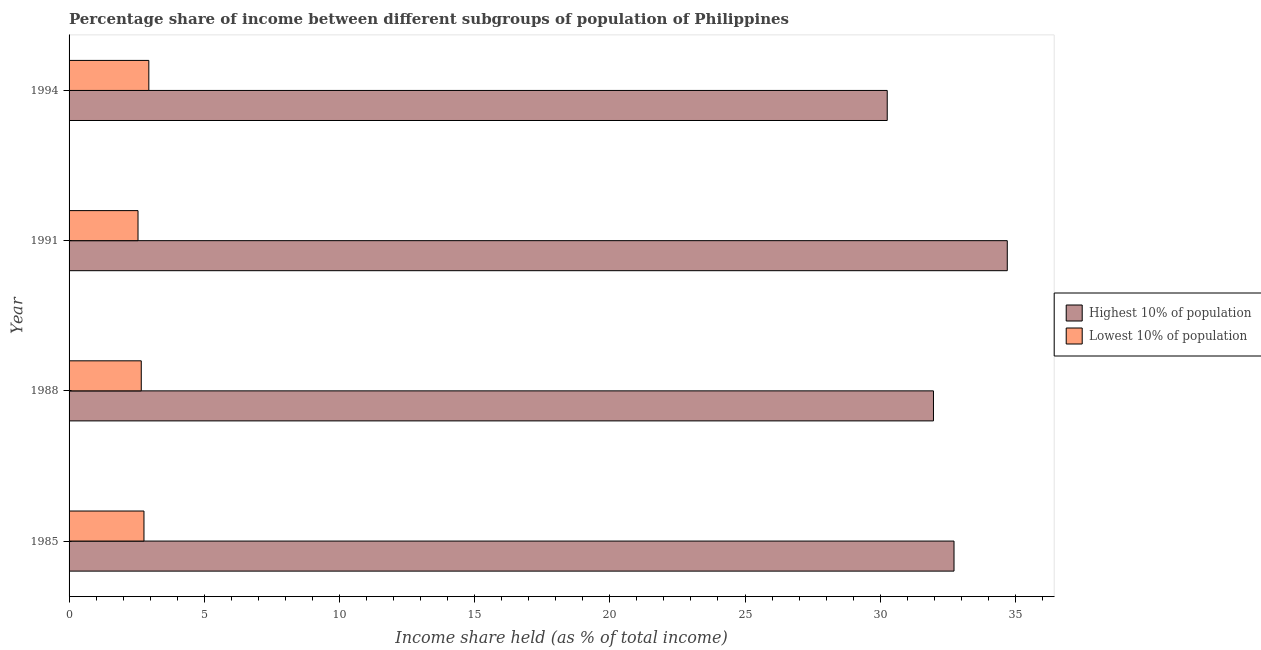How many groups of bars are there?
Make the answer very short. 4. Are the number of bars on each tick of the Y-axis equal?
Provide a succinct answer. Yes. How many bars are there on the 1st tick from the bottom?
Your answer should be compact. 2. What is the income share held by lowest 10% of the population in 1994?
Offer a terse response. 2.95. Across all years, what is the maximum income share held by highest 10% of the population?
Offer a terse response. 34.7. Across all years, what is the minimum income share held by lowest 10% of the population?
Provide a succinct answer. 2.55. In which year was the income share held by lowest 10% of the population minimum?
Offer a terse response. 1991. What is the total income share held by lowest 10% of the population in the graph?
Your answer should be compact. 10.94. What is the difference between the income share held by highest 10% of the population in 1985 and that in 1991?
Your response must be concise. -1.97. What is the difference between the income share held by lowest 10% of the population in 1991 and the income share held by highest 10% of the population in 1994?
Make the answer very short. -27.71. What is the average income share held by lowest 10% of the population per year?
Ensure brevity in your answer.  2.73. In the year 1988, what is the difference between the income share held by lowest 10% of the population and income share held by highest 10% of the population?
Your answer should be very brief. -29.3. In how many years, is the income share held by highest 10% of the population greater than 33 %?
Give a very brief answer. 1. What is the ratio of the income share held by lowest 10% of the population in 1988 to that in 1991?
Keep it short and to the point. 1.05. Is the difference between the income share held by lowest 10% of the population in 1988 and 1991 greater than the difference between the income share held by highest 10% of the population in 1988 and 1991?
Provide a succinct answer. Yes. What is the difference between the highest and the second highest income share held by highest 10% of the population?
Provide a succinct answer. 1.97. What is the difference between the highest and the lowest income share held by lowest 10% of the population?
Keep it short and to the point. 0.4. What does the 1st bar from the top in 1985 represents?
Provide a succinct answer. Lowest 10% of population. What does the 1st bar from the bottom in 1988 represents?
Offer a terse response. Highest 10% of population. Are all the bars in the graph horizontal?
Provide a succinct answer. Yes. How many years are there in the graph?
Keep it short and to the point. 4. Are the values on the major ticks of X-axis written in scientific E-notation?
Provide a succinct answer. No. Does the graph contain any zero values?
Your answer should be compact. No. Does the graph contain grids?
Offer a terse response. No. How are the legend labels stacked?
Your answer should be compact. Vertical. What is the title of the graph?
Keep it short and to the point. Percentage share of income between different subgroups of population of Philippines. What is the label or title of the X-axis?
Offer a terse response. Income share held (as % of total income). What is the Income share held (as % of total income) in Highest 10% of population in 1985?
Offer a very short reply. 32.73. What is the Income share held (as % of total income) in Lowest 10% of population in 1985?
Give a very brief answer. 2.77. What is the Income share held (as % of total income) of Highest 10% of population in 1988?
Give a very brief answer. 31.97. What is the Income share held (as % of total income) in Lowest 10% of population in 1988?
Provide a succinct answer. 2.67. What is the Income share held (as % of total income) in Highest 10% of population in 1991?
Your answer should be very brief. 34.7. What is the Income share held (as % of total income) in Lowest 10% of population in 1991?
Offer a terse response. 2.55. What is the Income share held (as % of total income) in Highest 10% of population in 1994?
Offer a very short reply. 30.26. What is the Income share held (as % of total income) in Lowest 10% of population in 1994?
Provide a short and direct response. 2.95. Across all years, what is the maximum Income share held (as % of total income) of Highest 10% of population?
Provide a succinct answer. 34.7. Across all years, what is the maximum Income share held (as % of total income) of Lowest 10% of population?
Make the answer very short. 2.95. Across all years, what is the minimum Income share held (as % of total income) in Highest 10% of population?
Ensure brevity in your answer.  30.26. Across all years, what is the minimum Income share held (as % of total income) of Lowest 10% of population?
Your answer should be compact. 2.55. What is the total Income share held (as % of total income) of Highest 10% of population in the graph?
Offer a terse response. 129.66. What is the total Income share held (as % of total income) of Lowest 10% of population in the graph?
Make the answer very short. 10.94. What is the difference between the Income share held (as % of total income) in Highest 10% of population in 1985 and that in 1988?
Your answer should be very brief. 0.76. What is the difference between the Income share held (as % of total income) of Highest 10% of population in 1985 and that in 1991?
Keep it short and to the point. -1.97. What is the difference between the Income share held (as % of total income) of Lowest 10% of population in 1985 and that in 1991?
Give a very brief answer. 0.22. What is the difference between the Income share held (as % of total income) of Highest 10% of population in 1985 and that in 1994?
Offer a very short reply. 2.47. What is the difference between the Income share held (as % of total income) of Lowest 10% of population in 1985 and that in 1994?
Ensure brevity in your answer.  -0.18. What is the difference between the Income share held (as % of total income) in Highest 10% of population in 1988 and that in 1991?
Make the answer very short. -2.73. What is the difference between the Income share held (as % of total income) in Lowest 10% of population in 1988 and that in 1991?
Your answer should be compact. 0.12. What is the difference between the Income share held (as % of total income) of Highest 10% of population in 1988 and that in 1994?
Your response must be concise. 1.71. What is the difference between the Income share held (as % of total income) of Lowest 10% of population in 1988 and that in 1994?
Ensure brevity in your answer.  -0.28. What is the difference between the Income share held (as % of total income) in Highest 10% of population in 1991 and that in 1994?
Provide a short and direct response. 4.44. What is the difference between the Income share held (as % of total income) of Lowest 10% of population in 1991 and that in 1994?
Offer a terse response. -0.4. What is the difference between the Income share held (as % of total income) in Highest 10% of population in 1985 and the Income share held (as % of total income) in Lowest 10% of population in 1988?
Your response must be concise. 30.06. What is the difference between the Income share held (as % of total income) in Highest 10% of population in 1985 and the Income share held (as % of total income) in Lowest 10% of population in 1991?
Offer a very short reply. 30.18. What is the difference between the Income share held (as % of total income) in Highest 10% of population in 1985 and the Income share held (as % of total income) in Lowest 10% of population in 1994?
Offer a terse response. 29.78. What is the difference between the Income share held (as % of total income) in Highest 10% of population in 1988 and the Income share held (as % of total income) in Lowest 10% of population in 1991?
Make the answer very short. 29.42. What is the difference between the Income share held (as % of total income) of Highest 10% of population in 1988 and the Income share held (as % of total income) of Lowest 10% of population in 1994?
Keep it short and to the point. 29.02. What is the difference between the Income share held (as % of total income) of Highest 10% of population in 1991 and the Income share held (as % of total income) of Lowest 10% of population in 1994?
Ensure brevity in your answer.  31.75. What is the average Income share held (as % of total income) in Highest 10% of population per year?
Make the answer very short. 32.41. What is the average Income share held (as % of total income) in Lowest 10% of population per year?
Offer a terse response. 2.73. In the year 1985, what is the difference between the Income share held (as % of total income) of Highest 10% of population and Income share held (as % of total income) of Lowest 10% of population?
Give a very brief answer. 29.96. In the year 1988, what is the difference between the Income share held (as % of total income) in Highest 10% of population and Income share held (as % of total income) in Lowest 10% of population?
Keep it short and to the point. 29.3. In the year 1991, what is the difference between the Income share held (as % of total income) in Highest 10% of population and Income share held (as % of total income) in Lowest 10% of population?
Make the answer very short. 32.15. In the year 1994, what is the difference between the Income share held (as % of total income) of Highest 10% of population and Income share held (as % of total income) of Lowest 10% of population?
Provide a short and direct response. 27.31. What is the ratio of the Income share held (as % of total income) in Highest 10% of population in 1985 to that in 1988?
Your answer should be compact. 1.02. What is the ratio of the Income share held (as % of total income) of Lowest 10% of population in 1985 to that in 1988?
Provide a short and direct response. 1.04. What is the ratio of the Income share held (as % of total income) in Highest 10% of population in 1985 to that in 1991?
Keep it short and to the point. 0.94. What is the ratio of the Income share held (as % of total income) in Lowest 10% of population in 1985 to that in 1991?
Give a very brief answer. 1.09. What is the ratio of the Income share held (as % of total income) in Highest 10% of population in 1985 to that in 1994?
Offer a very short reply. 1.08. What is the ratio of the Income share held (as % of total income) in Lowest 10% of population in 1985 to that in 1994?
Your answer should be very brief. 0.94. What is the ratio of the Income share held (as % of total income) of Highest 10% of population in 1988 to that in 1991?
Make the answer very short. 0.92. What is the ratio of the Income share held (as % of total income) in Lowest 10% of population in 1988 to that in 1991?
Make the answer very short. 1.05. What is the ratio of the Income share held (as % of total income) in Highest 10% of population in 1988 to that in 1994?
Your answer should be compact. 1.06. What is the ratio of the Income share held (as % of total income) of Lowest 10% of population in 1988 to that in 1994?
Ensure brevity in your answer.  0.91. What is the ratio of the Income share held (as % of total income) in Highest 10% of population in 1991 to that in 1994?
Keep it short and to the point. 1.15. What is the ratio of the Income share held (as % of total income) of Lowest 10% of population in 1991 to that in 1994?
Offer a very short reply. 0.86. What is the difference between the highest and the second highest Income share held (as % of total income) of Highest 10% of population?
Give a very brief answer. 1.97. What is the difference between the highest and the second highest Income share held (as % of total income) of Lowest 10% of population?
Your answer should be compact. 0.18. What is the difference between the highest and the lowest Income share held (as % of total income) of Highest 10% of population?
Your answer should be very brief. 4.44. What is the difference between the highest and the lowest Income share held (as % of total income) of Lowest 10% of population?
Your response must be concise. 0.4. 